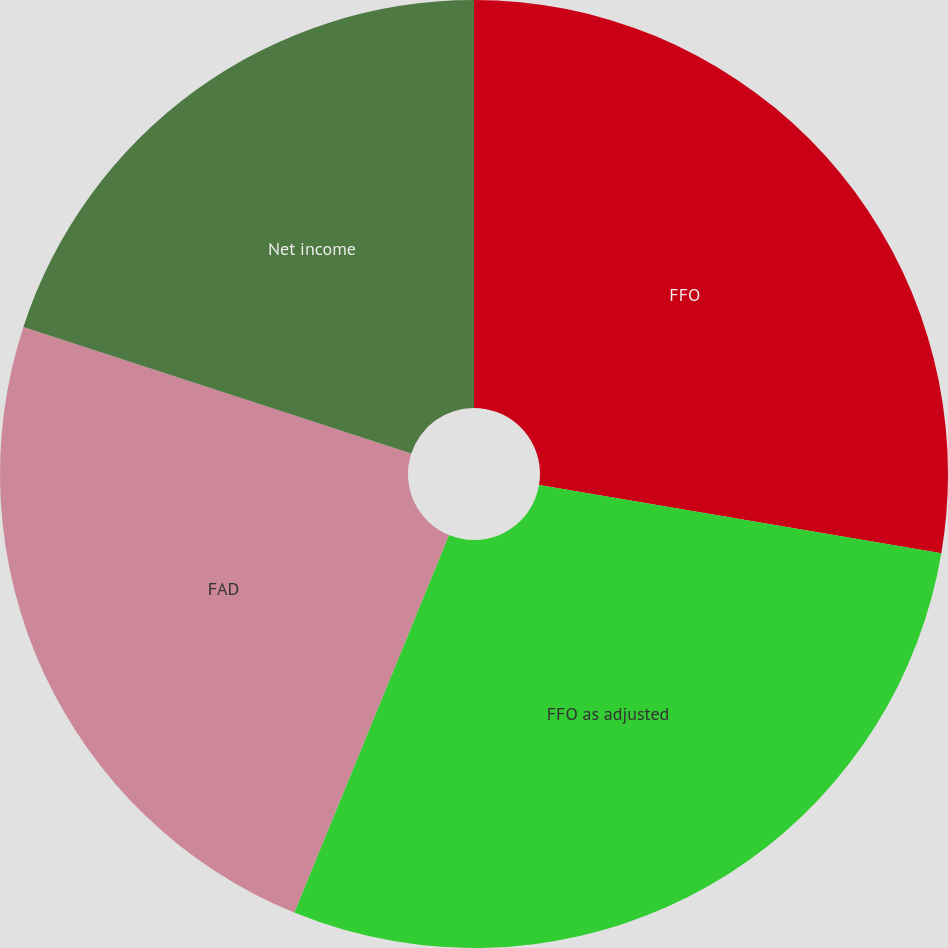Convert chart. <chart><loc_0><loc_0><loc_500><loc_500><pie_chart><fcel>FFO<fcel>FFO as adjusted<fcel>FAD<fcel>Net income<nl><fcel>27.67%<fcel>28.52%<fcel>23.83%<fcel>19.98%<nl></chart> 